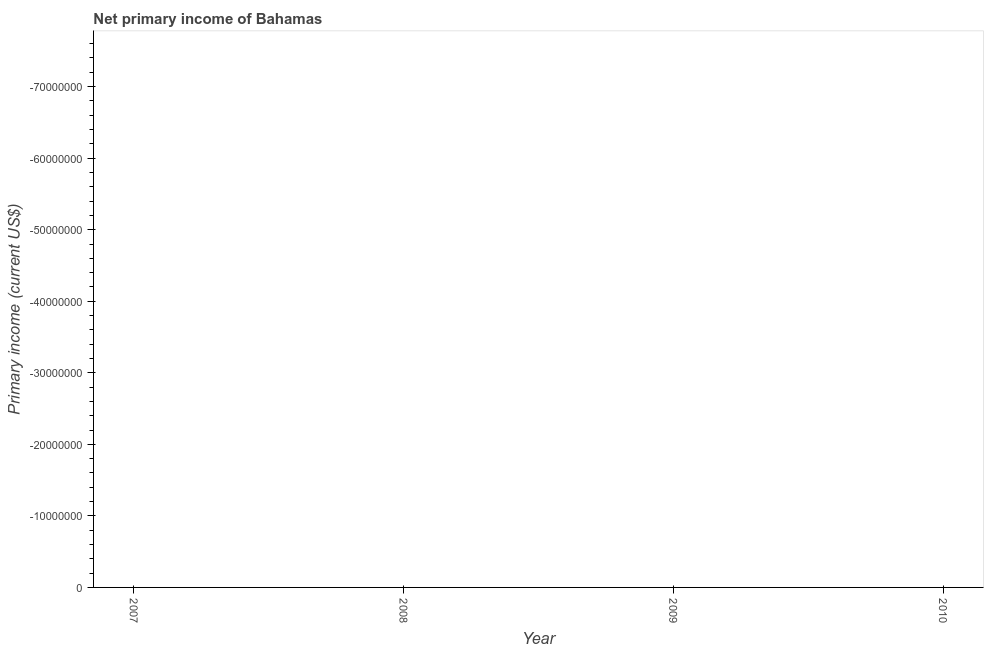What is the sum of the amount of primary income?
Offer a very short reply. 0. What is the average amount of primary income per year?
Provide a short and direct response. 0. In how many years, is the amount of primary income greater than -20000000 US$?
Keep it short and to the point. 0. Are the values on the major ticks of Y-axis written in scientific E-notation?
Give a very brief answer. No. Does the graph contain grids?
Keep it short and to the point. No. What is the title of the graph?
Offer a very short reply. Net primary income of Bahamas. What is the label or title of the X-axis?
Keep it short and to the point. Year. What is the label or title of the Y-axis?
Make the answer very short. Primary income (current US$). What is the Primary income (current US$) in 2007?
Offer a very short reply. 0. What is the Primary income (current US$) in 2010?
Keep it short and to the point. 0. 